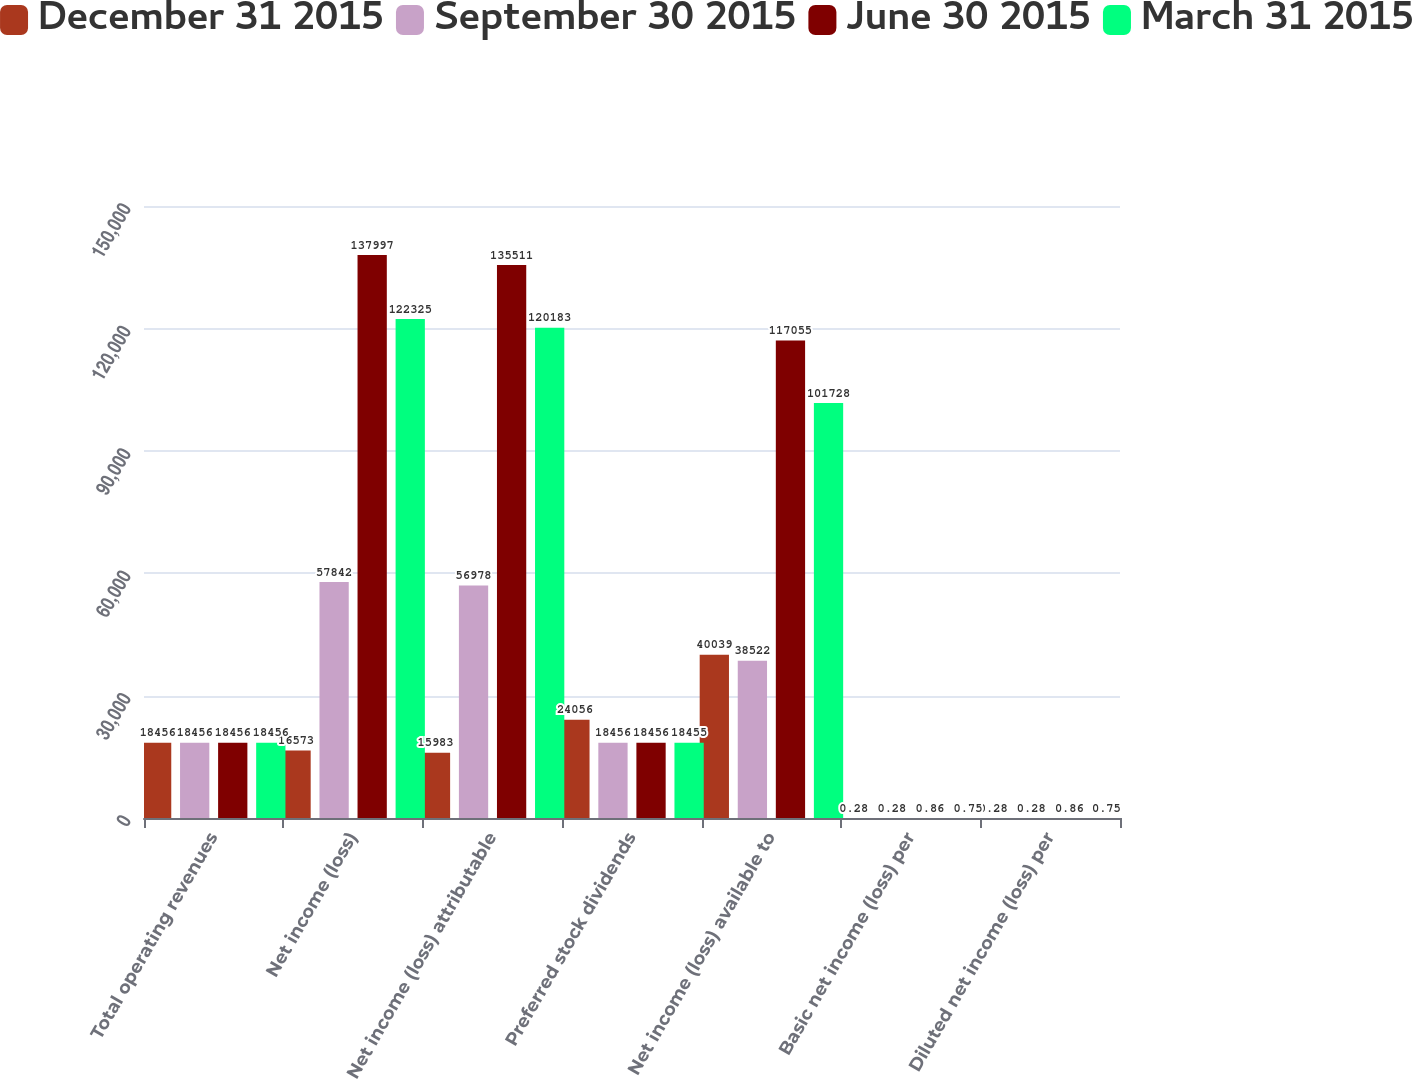Convert chart to OTSL. <chart><loc_0><loc_0><loc_500><loc_500><stacked_bar_chart><ecel><fcel>Total operating revenues<fcel>Net income (loss)<fcel>Net income (loss) attributable<fcel>Preferred stock dividends<fcel>Net income (loss) available to<fcel>Basic net income (loss) per<fcel>Diluted net income (loss) per<nl><fcel>December 31 2015<fcel>18456<fcel>16573<fcel>15983<fcel>24056<fcel>40039<fcel>0.28<fcel>0.28<nl><fcel>September 30 2015<fcel>18456<fcel>57842<fcel>56978<fcel>18456<fcel>38522<fcel>0.28<fcel>0.28<nl><fcel>June 30 2015<fcel>18456<fcel>137997<fcel>135511<fcel>18456<fcel>117055<fcel>0.86<fcel>0.86<nl><fcel>March 31 2015<fcel>18456<fcel>122325<fcel>120183<fcel>18455<fcel>101728<fcel>0.75<fcel>0.75<nl></chart> 